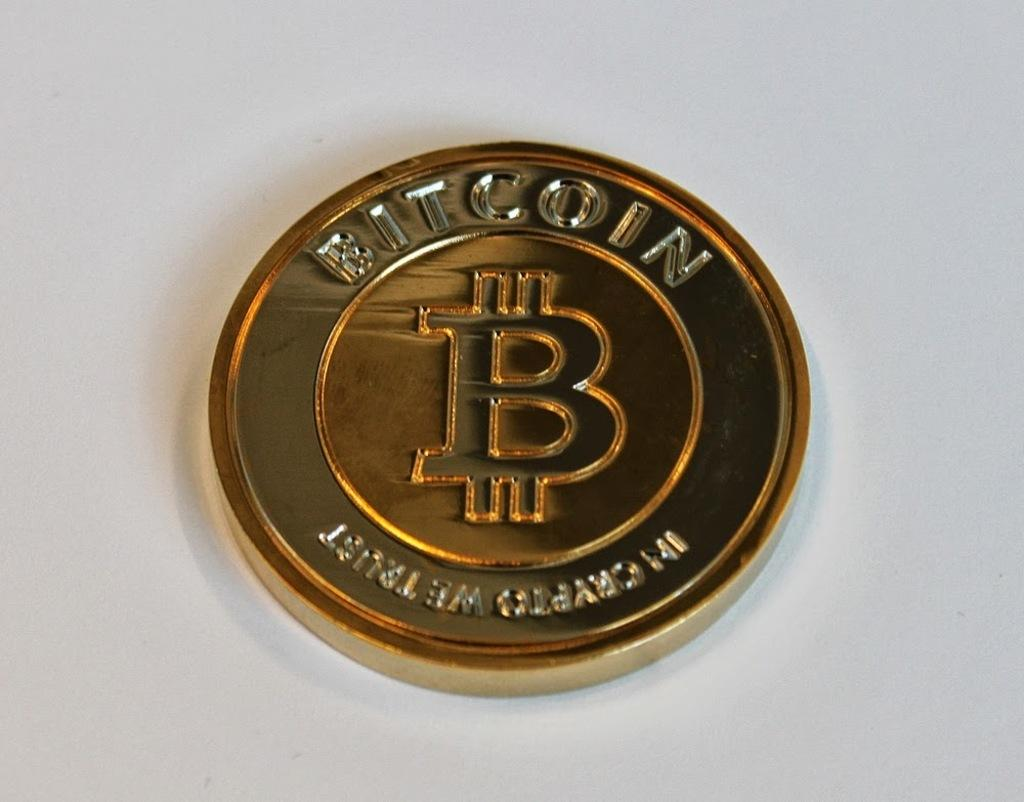<image>
Create a compact narrative representing the image presented. a Bit Coin golden coin reading In Crypto We Trust 